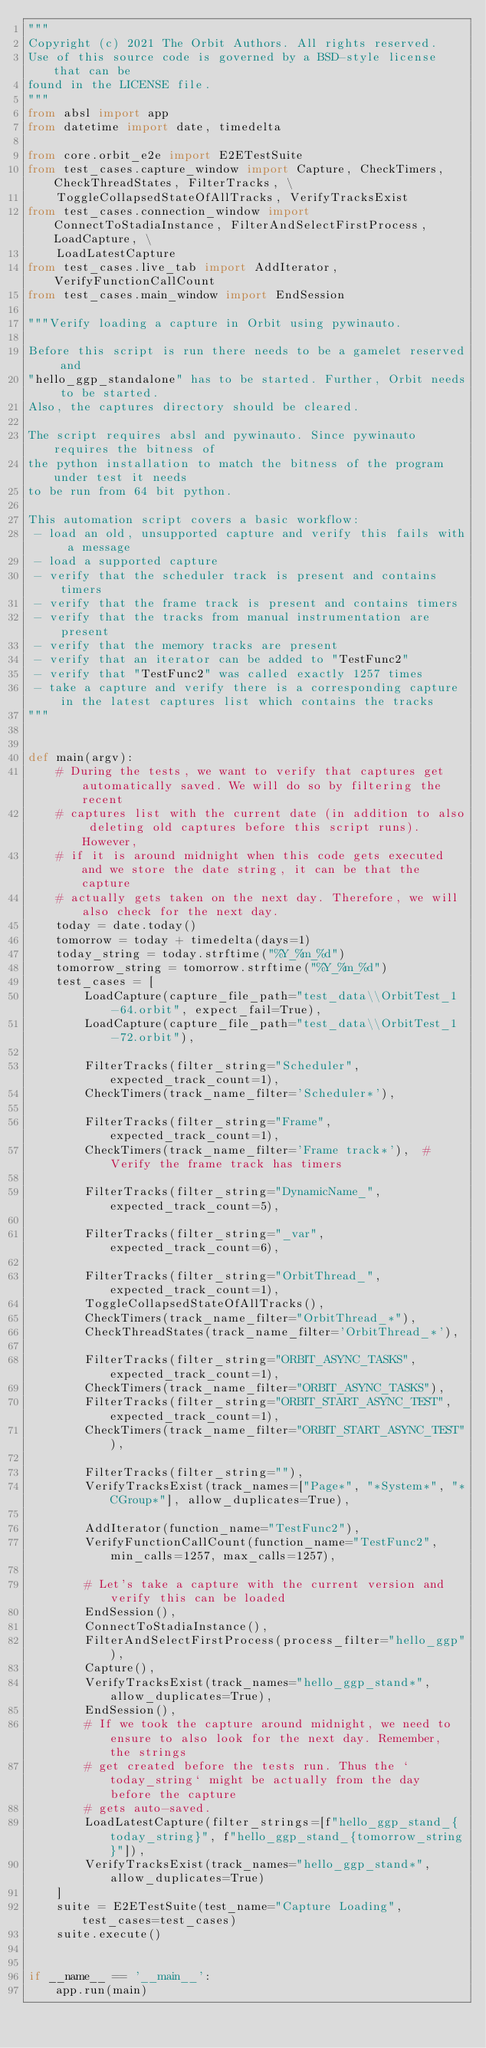<code> <loc_0><loc_0><loc_500><loc_500><_Python_>"""
Copyright (c) 2021 The Orbit Authors. All rights reserved.
Use of this source code is governed by a BSD-style license that can be
found in the LICENSE file.
"""
from absl import app
from datetime import date, timedelta

from core.orbit_e2e import E2ETestSuite
from test_cases.capture_window import Capture, CheckTimers, CheckThreadStates, FilterTracks, \
    ToggleCollapsedStateOfAllTracks, VerifyTracksExist
from test_cases.connection_window import ConnectToStadiaInstance, FilterAndSelectFirstProcess, LoadCapture, \
    LoadLatestCapture
from test_cases.live_tab import AddIterator, VerifyFunctionCallCount
from test_cases.main_window import EndSession

"""Verify loading a capture in Orbit using pywinauto.

Before this script is run there needs to be a gamelet reserved and
"hello_ggp_standalone" has to be started. Further, Orbit needs to be started.
Also, the captures directory should be cleared.

The script requires absl and pywinauto. Since pywinauto requires the bitness of
the python installation to match the bitness of the program under test it needs
to be run from 64 bit python.

This automation script covers a basic workflow:
 - load an old, unsupported capture and verify this fails with a message
 - load a supported capture
 - verify that the scheduler track is present and contains timers
 - verify that the frame track is present and contains timers
 - verify that the tracks from manual instrumentation are present
 - verify that the memory tracks are present
 - verify that an iterator can be added to "TestFunc2"
 - verify that "TestFunc2" was called exactly 1257 times
 - take a capture and verify there is a corresponding capture in the latest captures list which contains the tracks
"""


def main(argv):
    # During the tests, we want to verify that captures get automatically saved. We will do so by filtering the recent
    # captures list with the current date (in addition to also deleting old captures before this script runs). However,
    # if it is around midnight when this code gets executed and we store the date string, it can be that the capture
    # actually gets taken on the next day. Therefore, we will also check for the next day.
    today = date.today()
    tomorrow = today + timedelta(days=1)
    today_string = today.strftime("%Y_%m_%d")
    tomorrow_string = tomorrow.strftime("%Y_%m_%d")
    test_cases = [
        LoadCapture(capture_file_path="test_data\\OrbitTest_1-64.orbit", expect_fail=True),
        LoadCapture(capture_file_path="test_data\\OrbitTest_1-72.orbit"),

        FilterTracks(filter_string="Scheduler", expected_track_count=1),
        CheckTimers(track_name_filter='Scheduler*'),

        FilterTracks(filter_string="Frame", expected_track_count=1),
        CheckTimers(track_name_filter='Frame track*'),  # Verify the frame track has timers

        FilterTracks(filter_string="DynamicName_", expected_track_count=5),

        FilterTracks(filter_string="_var", expected_track_count=6),

        FilterTracks(filter_string="OrbitThread_", expected_track_count=1),
        ToggleCollapsedStateOfAllTracks(),
        CheckTimers(track_name_filter="OrbitThread_*"),
        CheckThreadStates(track_name_filter='OrbitThread_*'),

        FilterTracks(filter_string="ORBIT_ASYNC_TASKS", expected_track_count=1),
        CheckTimers(track_name_filter="ORBIT_ASYNC_TASKS"),
        FilterTracks(filter_string="ORBIT_START_ASYNC_TEST", expected_track_count=1),
        CheckTimers(track_name_filter="ORBIT_START_ASYNC_TEST"),

        FilterTracks(filter_string=""),
        VerifyTracksExist(track_names=["Page*", "*System*", "*CGroup*"], allow_duplicates=True),

        AddIterator(function_name="TestFunc2"),
        VerifyFunctionCallCount(function_name="TestFunc2", min_calls=1257, max_calls=1257),

        # Let's take a capture with the current version and verify this can be loaded
        EndSession(),
        ConnectToStadiaInstance(),
        FilterAndSelectFirstProcess(process_filter="hello_ggp"),
        Capture(),
        VerifyTracksExist(track_names="hello_ggp_stand*", allow_duplicates=True),
        EndSession(),
        # If we took the capture around midnight, we need to ensure to also look for the next day. Remember, the strings
        # get created before the tests run. Thus the `today_string` might be actually from the day before the capture
        # gets auto-saved.
        LoadLatestCapture(filter_strings=[f"hello_ggp_stand_{today_string}", f"hello_ggp_stand_{tomorrow_string}"]),
        VerifyTracksExist(track_names="hello_ggp_stand*", allow_duplicates=True)
    ]
    suite = E2ETestSuite(test_name="Capture Loading", test_cases=test_cases)
    suite.execute()


if __name__ == '__main__':
    app.run(main)
</code> 